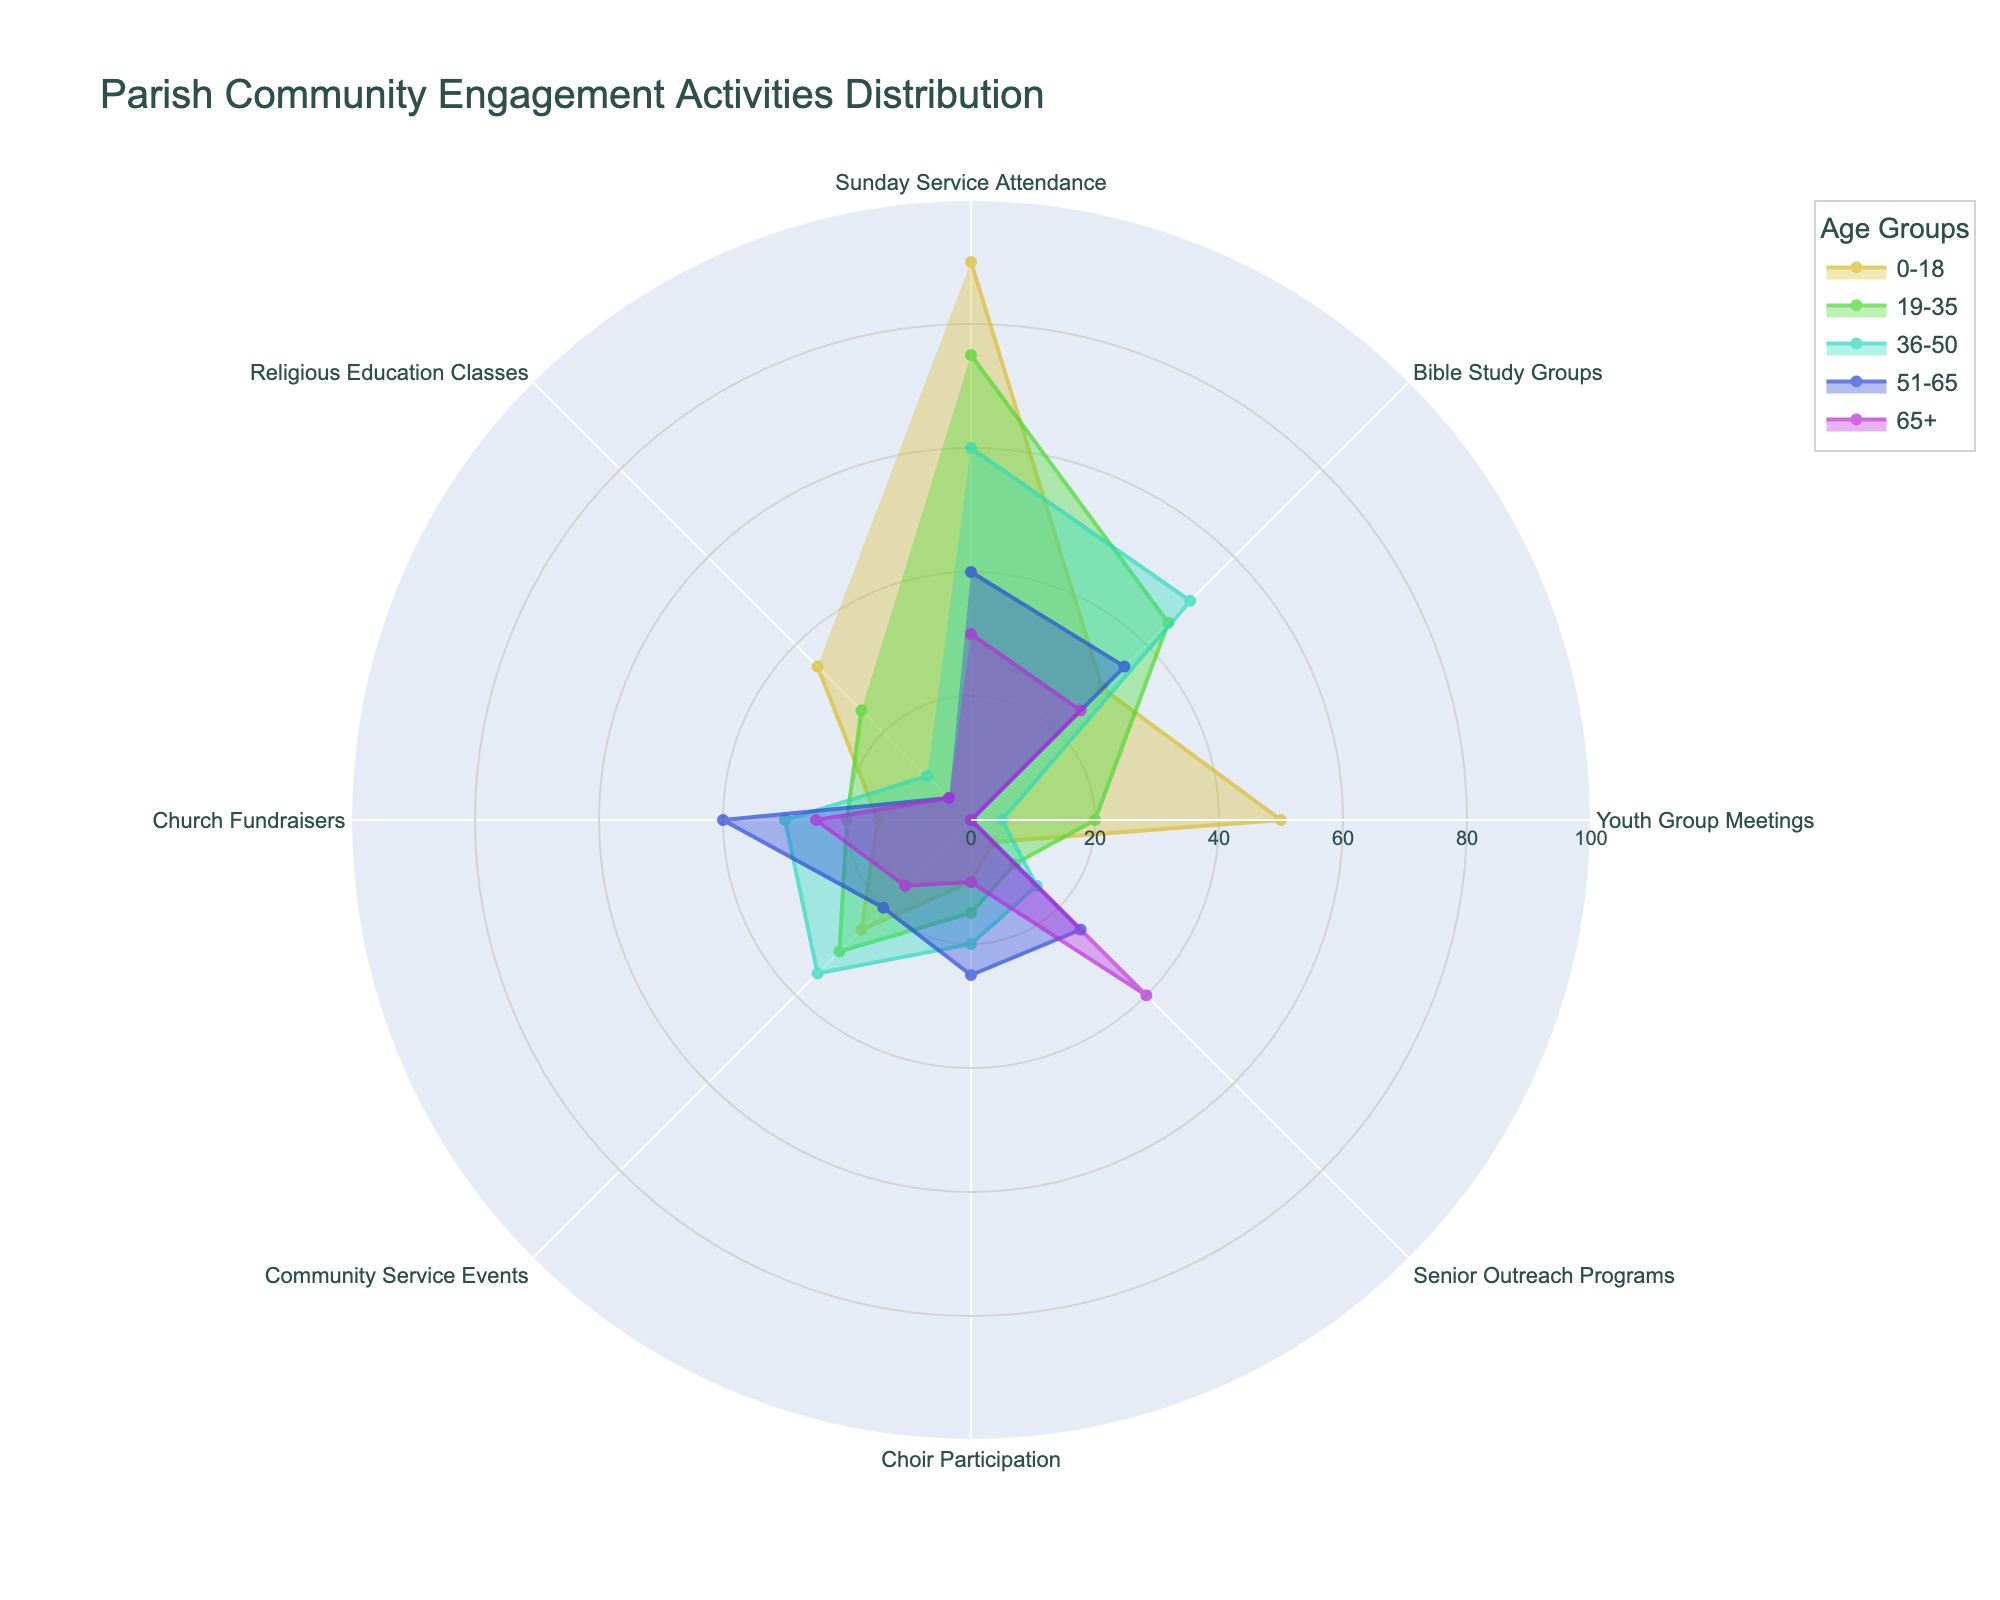What is the title of the figure? The title of the figure is prominently displayed at the top of the chart in larger font size for clear visibility.
Answer: Parish Community Engagement Activities Distribution Which age group shows the highest attendance in Sunday Service? By looking at the radial values for Sunday Service Attendance, the 0-18 age group has the highest value among all age groups.
Answer: 0-18 Which activity has the highest participation from the 51-65 age group? Observing the radial points for 51-65 age group, the highest value corresponds to Church Fundraisers.
Answer: Church Fundraisers What is the sum of participants in Community Service Events for all age groups? Adding the values for all age groups in Community Service Events: 25 + 30 + 35 + 20 + 15 = 125.
Answer: 125 How does the participation in Youth Group Meetings compare across different age groups? From the chart, Youth Group Meetings have the highest participation from 0-18, considerable drop to 19-35, and very low to non-existent participation in older age groups.
Answer: Highest in 0-18, low in others Which activity is least participated in by the 65+ age group? Examining the 65+ age group's radial points, Religious Education Classes have the lowest value.
Answer: Religious Education Classes What is the average participation in Bible Study Groups across all age groups? The values for Bible Study Groups are 30, 45, 50, 35, and 25. The sum is 185, divided by 5 age groups gives an average of 37.
Answer: 37 For the activity Senior Outreach Programs, which age group’s participation exceeds 20? Observing radial values for Senior Outreach Programs, only the 65+ age group shows participation exceeding 20.
Answer: 65+ Which activity shows the most consistent participation among the 36-50 age group and how do you know? By looking at the radial values for 36-50 age group, Community Service Events have a value similar to other activities, depicting consistency.
Answer: Community Service Events Compare the participation in Church Fundraisers between the 0-18 and 51-65 age groups. The values for Church Fundraisers are 15 for 0-18 and 40 for 51-65, showing 51-65 has significantly higher participation.
Answer: 51-65 higher than 0-18 